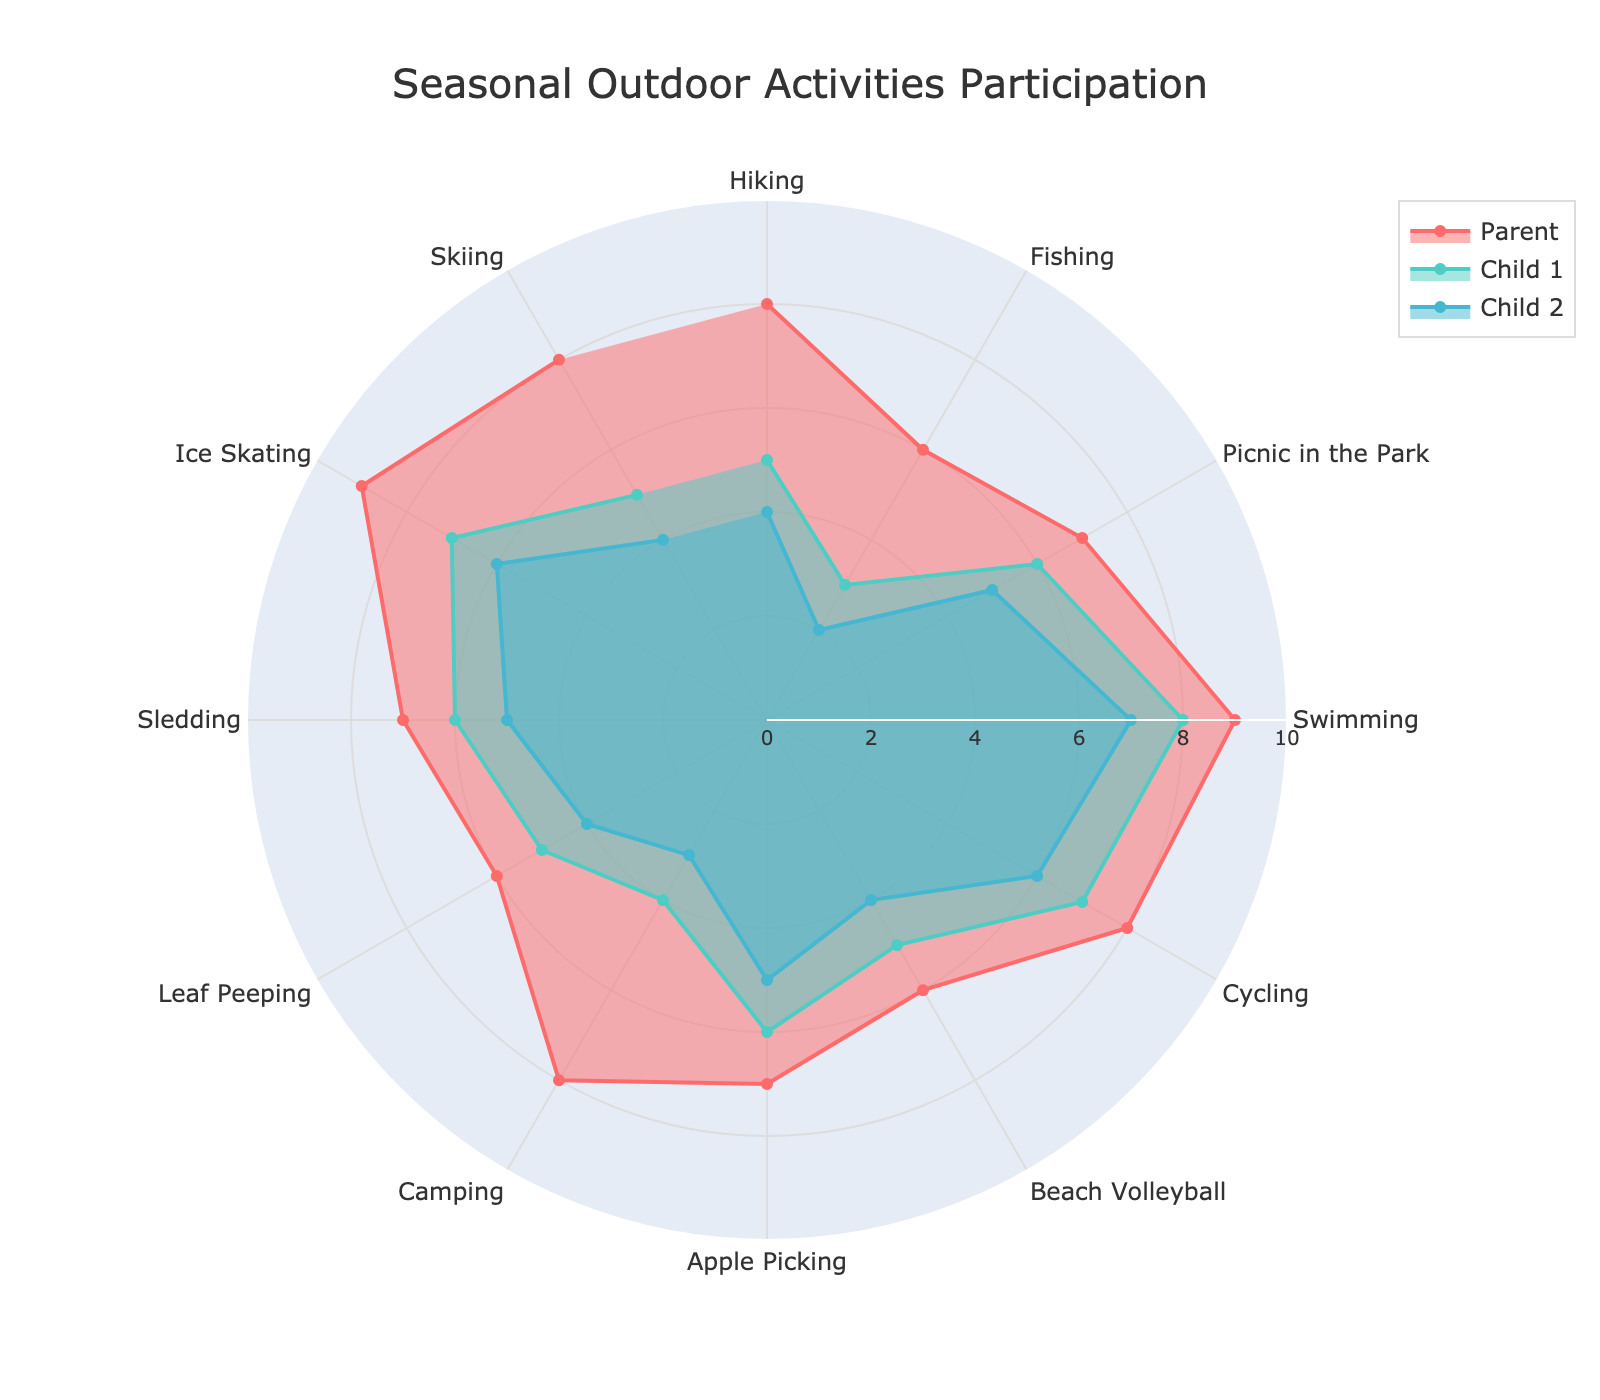What's the title of the chart? The title is displayed at the top of the chart. It reads "Seasonal Outdoor Activities Participation".
Answer: Seasonal Outdoor Activities Participation Which family member participates the most in Swimming? Look at the 'Swimming' activity and compare the radial lengths of Parent, Child 1, and Child 2. The parent's radial length is the longest at 9.
Answer: Parent Which activity in Spring has the highest participation from Child 1? Check the activities labeled under Spring and compare the radial lengths for Child 1. 'Picnic in the Park' has the highest value at 6.
Answer: Picnic in the Park What is the average participation of Child 2 in Winter activities? Identify the Winter activities ('Sledding', 'Ice Skating', 'Skiing') and sum the values for Child 2. They are 5, 6, and 4. Divide the sum (15) by the number of activities (3).
Answer: 5 How does parent's participation in 'Camping' compare to that of Child 1? Compare the radial lengths for the 'Camping' activity. Parent's value is 8, while Child 1's is 4.
Answer: Greater than Which season has the most diverse range of activities based on their participation values? Count the number of activities and compare the range of participation values for each season. Summer has three activities with a range of values from 6 to 9 for Parent, 5 to 8 for Child 1, and 4 to 7 for Child 2, suggesting a diverse range.
Answer: Summer Is anyone more active in Winter than they are in Spring? Total the participation values for Winter and Spring for each family member, then compare. For Parents, Winter sum is 7+9+8=24, and Spring is 8+6+7=21. Winter has a higher total for Parents.
Answer: Yes, Parent Which activity has an equal participation score from Child 1 and Child 2? Find activities where Child 1 and Child 2 have the same radial length. 'Sledding' has both values at 6 and 5, respectively, so no activity has equal participation.
Answer: None What is the difference in participation between Parent and Child 2 in 'Apple Picking'? Subtract Child 2's participation value (5) from Parent's value (7). The difference is 7 - 5.
Answer: 2 Which family member has the lowest participation in 'Fishing'? Compare the radial lengths for 'Fishing'. Child 2's value is the smallest at 2.
Answer: Child 2 